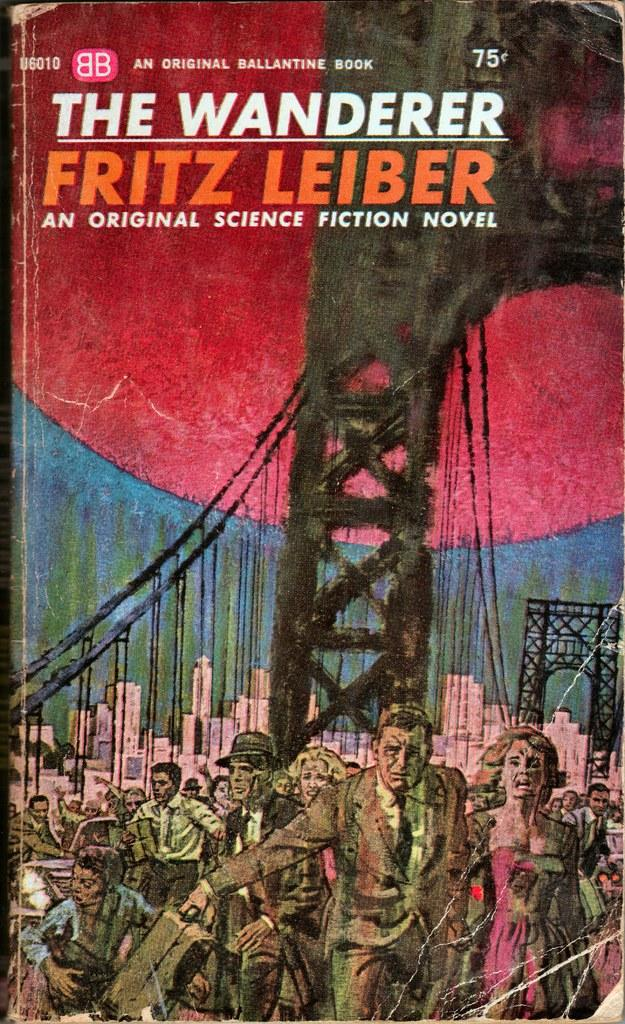<image>
Present a compact description of the photo's key features. a book called The Wanderer that is by Fritz Leiber 